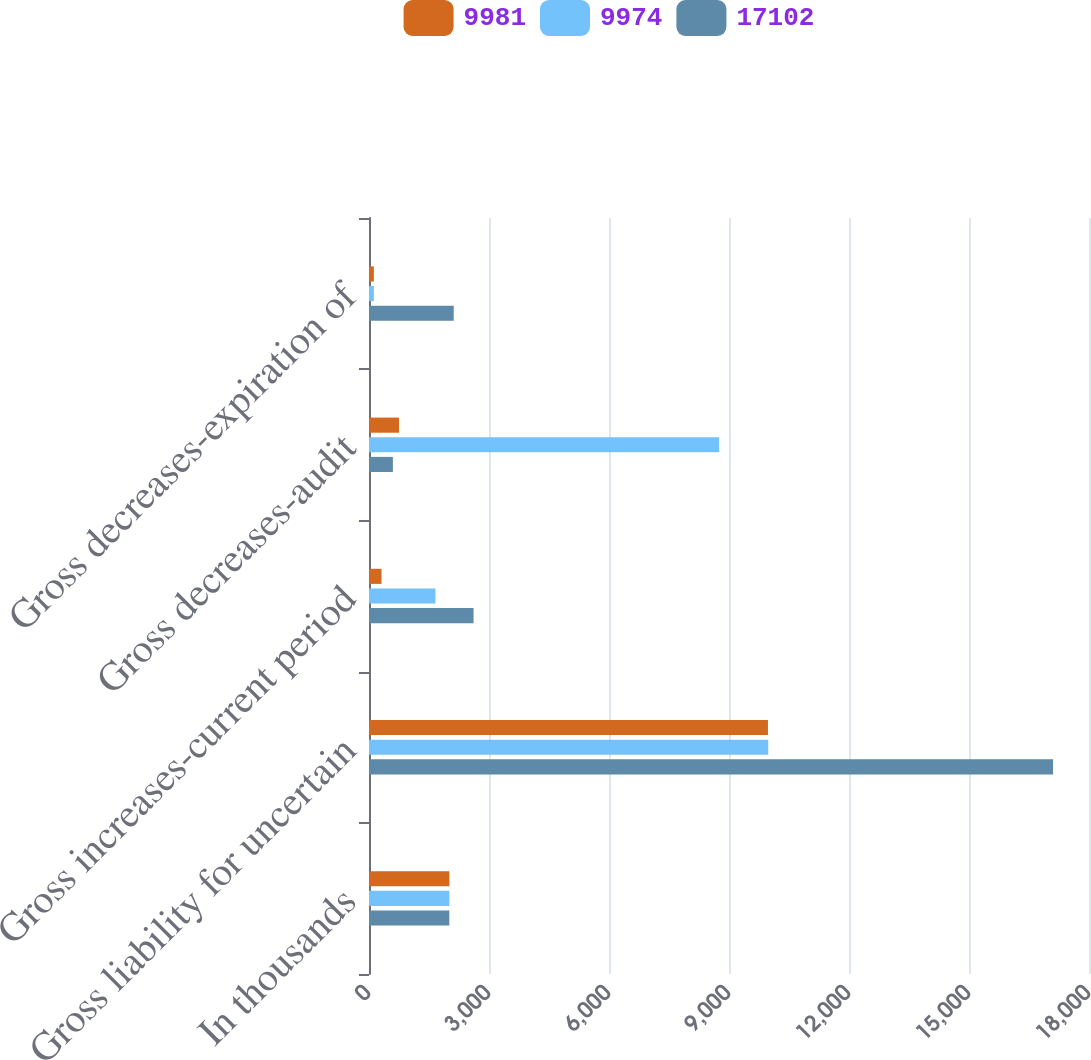Convert chart. <chart><loc_0><loc_0><loc_500><loc_500><stacked_bar_chart><ecel><fcel>In thousands<fcel>Gross liability for uncertain<fcel>Gross increases-current period<fcel>Gross decreases-audit<fcel>Gross decreases-expiration of<nl><fcel>9981<fcel>2010<fcel>9974<fcel>313<fcel>751<fcel>122<nl><fcel>9974<fcel>2009<fcel>9981<fcel>1661<fcel>8753<fcel>122<nl><fcel>17102<fcel>2008<fcel>17102<fcel>2614<fcel>597<fcel>2118<nl></chart> 